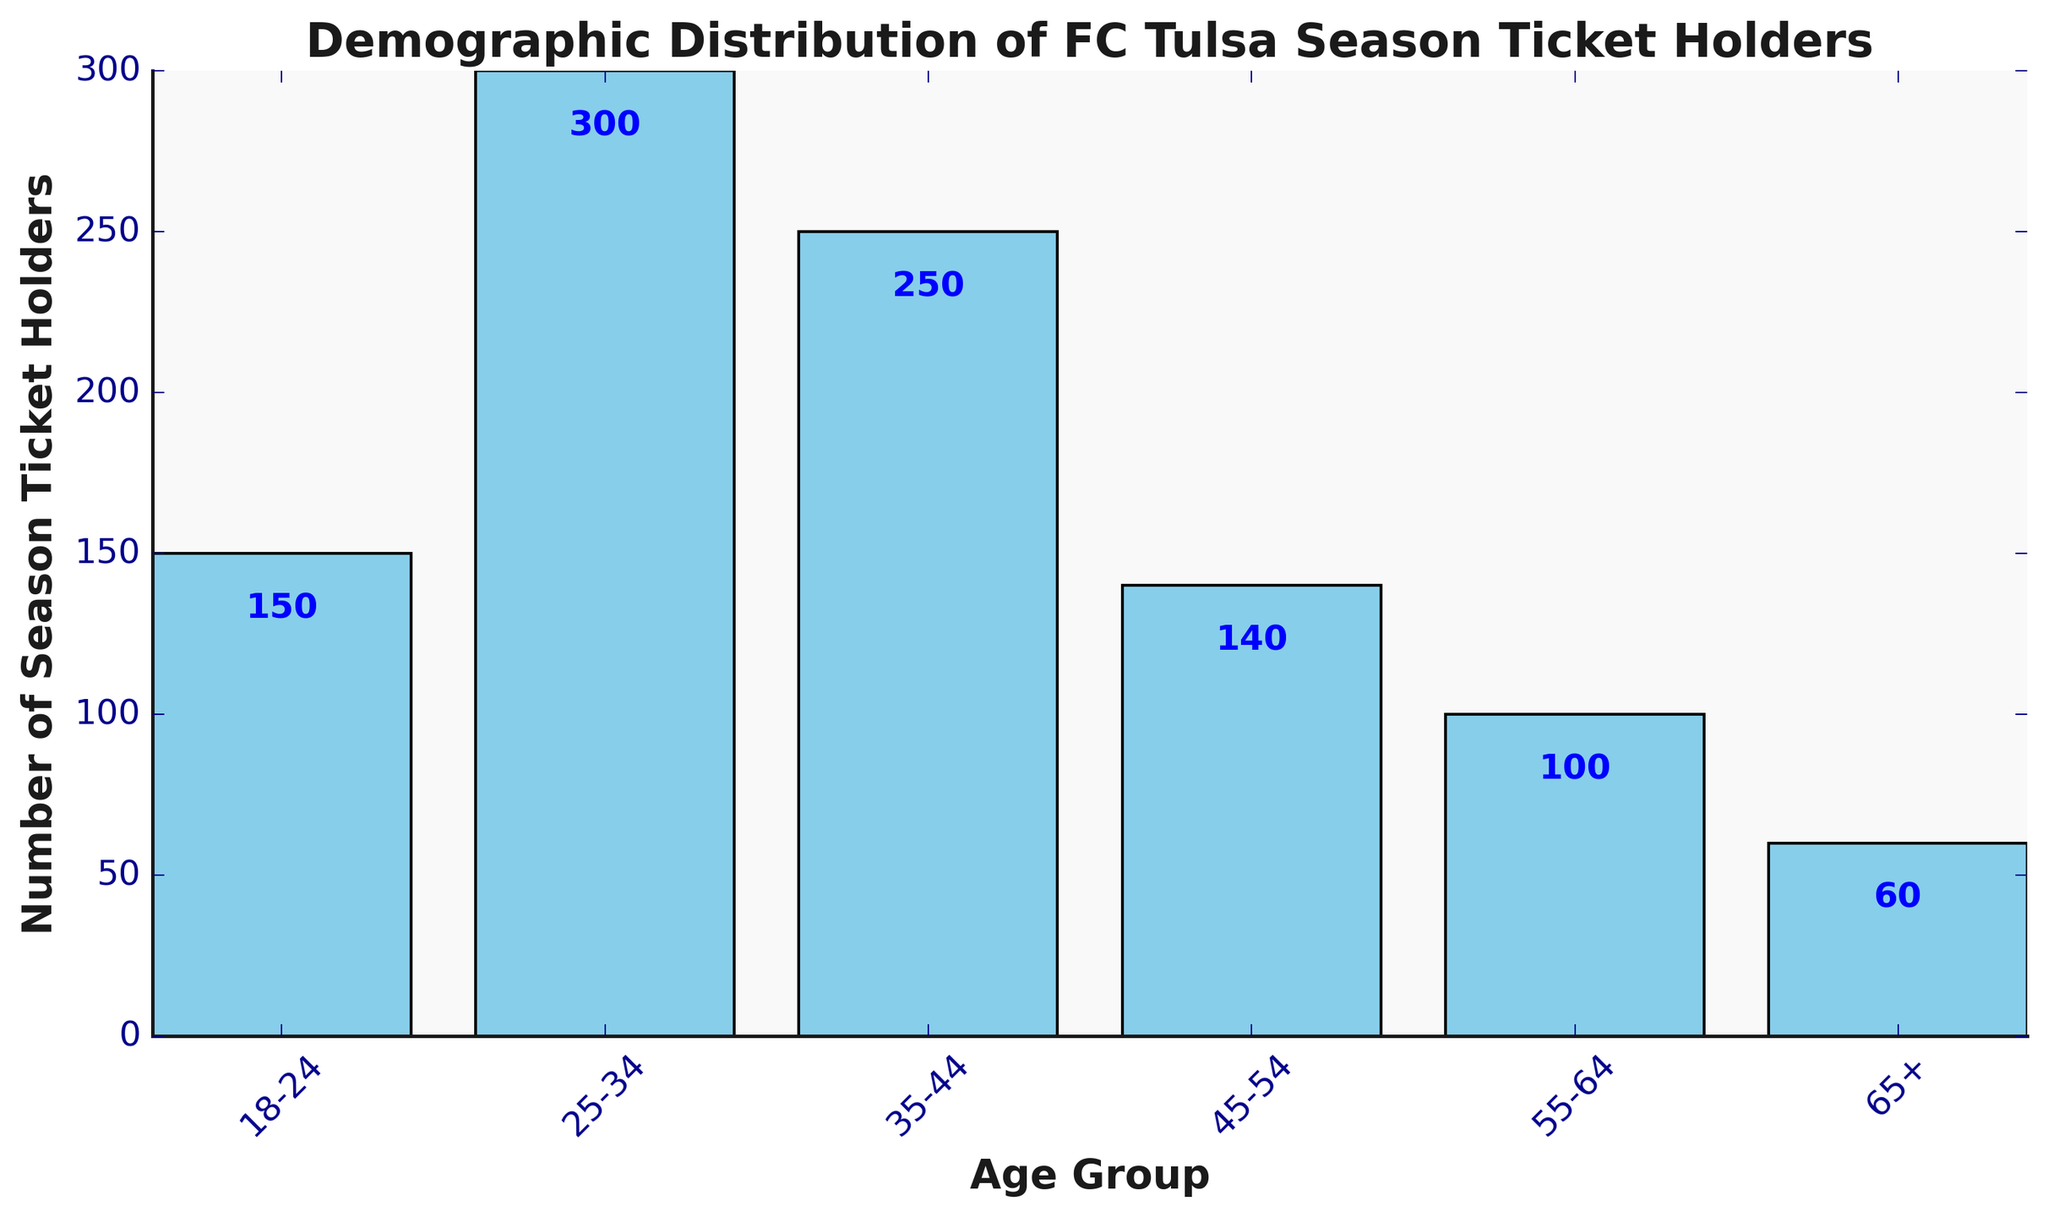What's the total number of season ticket holders for age groups 35-44 and 45-54 combined? To find the total, sum the number of ticket holders for age groups 35-44 and 45-54: 250 + 140 = 390
Answer: 390 Which age group has the highest number of season ticket holders? Look at the bar with the greatest height, which represents the age group 25-34 with 300 season ticket holders
Answer: 25-34 How much larger is the number of season ticket holders in the age group 25-34 compared to the age group 18-24? Subtract the number of ticket holders in the age group 18-24 from those in 25-34: 300 - 150 = 150
Answer: 150 What's the average number of season ticket holders for the age groups 18-24, 55-64, and 65+? Sum the number of ticket holders for these age groups and then divide by the number of groups: (150 + 100 + 60) / 3 = 310 / 3 ≈ 103.33
Answer: 103.33 Which age group has the smallest number of season ticket holders? Identify the bar with the shortest height, which represents the age group 65+ with 60 season ticket holders
Answer: 65+ What's the median number of season ticket holders among all age groups? Arrange the numbers in ascending order (60, 100, 140, 150, 250, 300) and find the middle value. Since there are six values, the median is the average of the third and fourth values: (140 + 150) / 2 = 145
Answer: 145 How many more season ticket holders are there in the age group 35-44 compared to the age group 55-64? Subtract the number of ticket holders in the age group 55-64 from those in 35-44: 250 - 100 = 150
Answer: 150 Which age groups have fewer than 150 season ticket holders? Identify the bars with heights less than 150, representing the age groups 45-54, 55-64, and 65+ with 140, 100, and 60 season ticket holders respectively
Answer: 45-54, 55-64, 65+ What is the approximate difference in height between the bars representing the age groups 25-34 and 65+? Visually estimate the difference in height between the highest and the shortest bars. The difference in the number of ticket holders is 300 - 60 = 240
Answer: 240 What color are the bars in the chart? The color of the bars can be observed directly, and they are marked in sky blue
Answer: Sky blue 